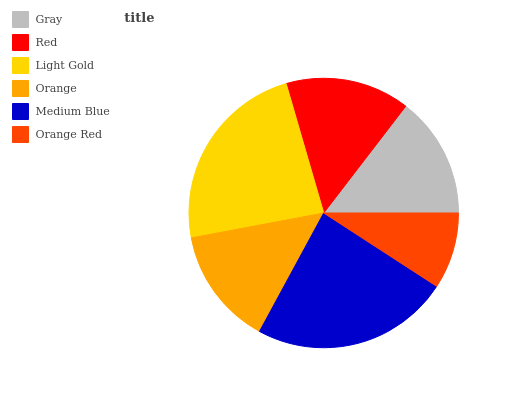Is Orange Red the minimum?
Answer yes or no. Yes. Is Medium Blue the maximum?
Answer yes or no. Yes. Is Red the minimum?
Answer yes or no. No. Is Red the maximum?
Answer yes or no. No. Is Red greater than Gray?
Answer yes or no. Yes. Is Gray less than Red?
Answer yes or no. Yes. Is Gray greater than Red?
Answer yes or no. No. Is Red less than Gray?
Answer yes or no. No. Is Red the high median?
Answer yes or no. Yes. Is Gray the low median?
Answer yes or no. Yes. Is Orange Red the high median?
Answer yes or no. No. Is Medium Blue the low median?
Answer yes or no. No. 